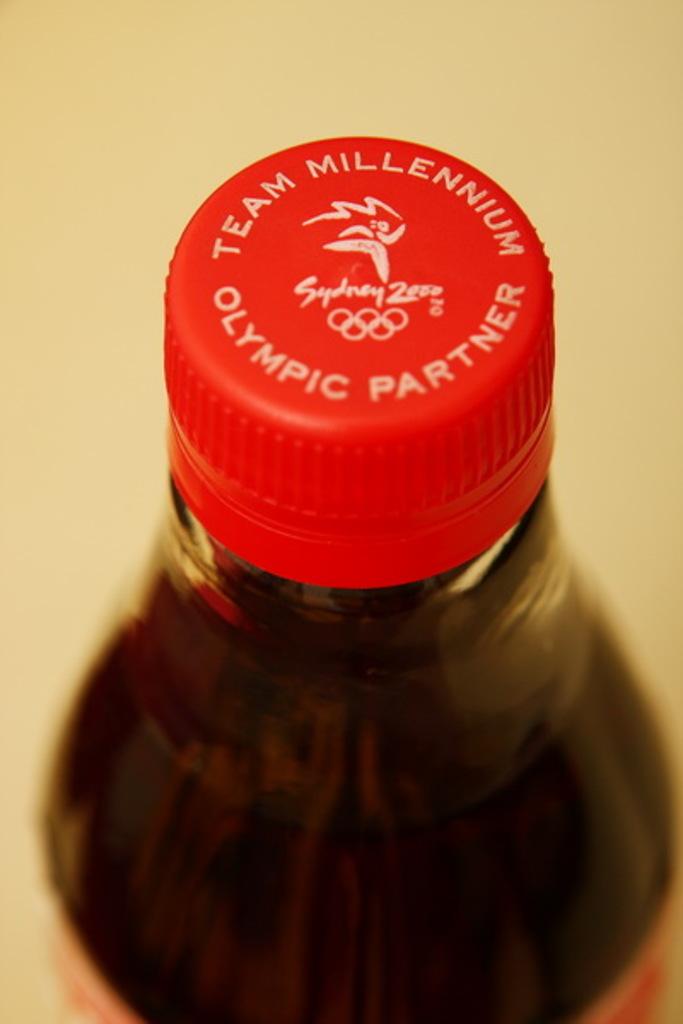What does this bottlecap say?
Offer a terse response. Team millennium olympic partner. What summer olympics is this beverage company sponsoring?
Keep it short and to the point. Sydney. 